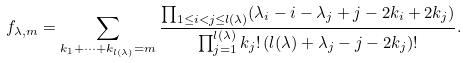<formula> <loc_0><loc_0><loc_500><loc_500>f _ { \lambda , m } = \sum _ { k _ { 1 } + \dots + k _ { l ( \lambda ) } = m } \frac { \prod _ { 1 \leq i < j \leq l ( \lambda ) } ( \lambda _ { i } - i - \lambda _ { j } + j - 2 k _ { i } + 2 k _ { j } ) } { \prod _ { j = 1 } ^ { l ( \lambda ) } { k _ { j } } ! \, ( l ( \lambda ) + \lambda _ { j } - j - 2 k _ { j } ) ! } .</formula> 